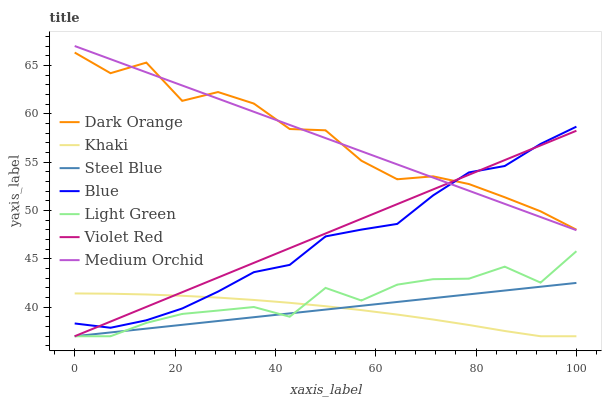Does Khaki have the minimum area under the curve?
Answer yes or no. Yes. Does Medium Orchid have the maximum area under the curve?
Answer yes or no. Yes. Does Dark Orange have the minimum area under the curve?
Answer yes or no. No. Does Dark Orange have the maximum area under the curve?
Answer yes or no. No. Is Steel Blue the smoothest?
Answer yes or no. Yes. Is Dark Orange the roughest?
Answer yes or no. Yes. Is Violet Red the smoothest?
Answer yes or no. No. Is Violet Red the roughest?
Answer yes or no. No. Does Dark Orange have the lowest value?
Answer yes or no. No. Does Dark Orange have the highest value?
Answer yes or no. No. Is Light Green less than Blue?
Answer yes or no. Yes. Is Blue greater than Steel Blue?
Answer yes or no. Yes. Does Light Green intersect Blue?
Answer yes or no. No. 